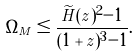<formula> <loc_0><loc_0><loc_500><loc_500>\Omega _ { M } \leq \frac { \widetilde { H } ( z ) ^ { 2 } - 1 } { ( 1 + z ) ^ { 3 } - 1 } .</formula> 